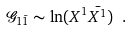Convert formula to latex. <formula><loc_0><loc_0><loc_500><loc_500>\mathcal { G } _ { 1 \bar { 1 } } \sim \ln ( X ^ { 1 } \bar { X ^ { 1 } } ) \ .</formula> 